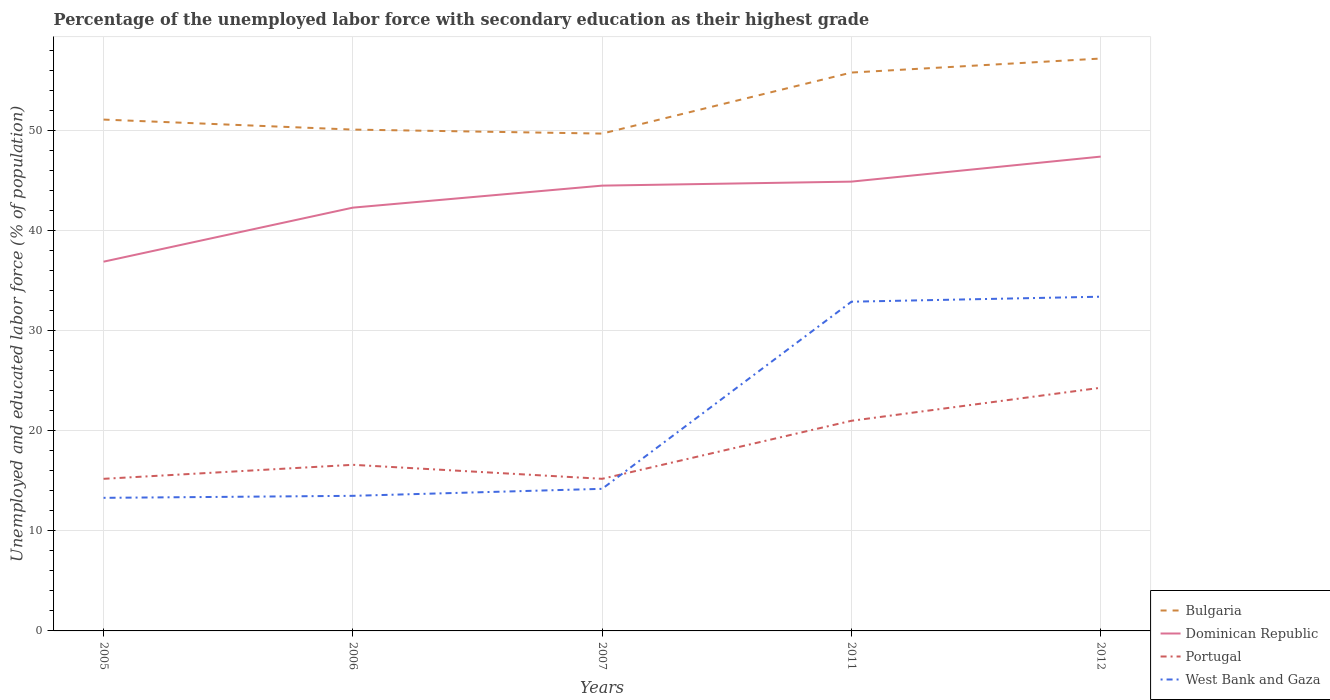How many different coloured lines are there?
Give a very brief answer. 4. Does the line corresponding to Dominican Republic intersect with the line corresponding to West Bank and Gaza?
Your answer should be compact. No. Is the number of lines equal to the number of legend labels?
Offer a very short reply. Yes. Across all years, what is the maximum percentage of the unemployed labor force with secondary education in West Bank and Gaza?
Offer a terse response. 13.3. What is the total percentage of the unemployed labor force with secondary education in Bulgaria in the graph?
Your answer should be very brief. -4.7. What is the difference between the highest and the lowest percentage of the unemployed labor force with secondary education in Dominican Republic?
Provide a succinct answer. 3. Is the percentage of the unemployed labor force with secondary education in West Bank and Gaza strictly greater than the percentage of the unemployed labor force with secondary education in Portugal over the years?
Your answer should be compact. No. How many lines are there?
Your response must be concise. 4. What is the difference between two consecutive major ticks on the Y-axis?
Your response must be concise. 10. Are the values on the major ticks of Y-axis written in scientific E-notation?
Offer a very short reply. No. Does the graph contain any zero values?
Offer a very short reply. No. How are the legend labels stacked?
Provide a succinct answer. Vertical. What is the title of the graph?
Ensure brevity in your answer.  Percentage of the unemployed labor force with secondary education as their highest grade. Does "Kyrgyz Republic" appear as one of the legend labels in the graph?
Your response must be concise. No. What is the label or title of the X-axis?
Offer a very short reply. Years. What is the label or title of the Y-axis?
Provide a succinct answer. Unemployed and educated labor force (% of population). What is the Unemployed and educated labor force (% of population) in Bulgaria in 2005?
Ensure brevity in your answer.  51.1. What is the Unemployed and educated labor force (% of population) in Dominican Republic in 2005?
Offer a terse response. 36.9. What is the Unemployed and educated labor force (% of population) of Portugal in 2005?
Make the answer very short. 15.2. What is the Unemployed and educated labor force (% of population) of West Bank and Gaza in 2005?
Ensure brevity in your answer.  13.3. What is the Unemployed and educated labor force (% of population) in Bulgaria in 2006?
Your answer should be compact. 50.1. What is the Unemployed and educated labor force (% of population) of Dominican Republic in 2006?
Offer a very short reply. 42.3. What is the Unemployed and educated labor force (% of population) of Portugal in 2006?
Provide a short and direct response. 16.6. What is the Unemployed and educated labor force (% of population) in Bulgaria in 2007?
Your answer should be compact. 49.7. What is the Unemployed and educated labor force (% of population) of Dominican Republic in 2007?
Keep it short and to the point. 44.5. What is the Unemployed and educated labor force (% of population) in Portugal in 2007?
Provide a succinct answer. 15.2. What is the Unemployed and educated labor force (% of population) in West Bank and Gaza in 2007?
Your answer should be very brief. 14.2. What is the Unemployed and educated labor force (% of population) of Bulgaria in 2011?
Offer a terse response. 55.8. What is the Unemployed and educated labor force (% of population) in Dominican Republic in 2011?
Offer a terse response. 44.9. What is the Unemployed and educated labor force (% of population) of Portugal in 2011?
Make the answer very short. 21. What is the Unemployed and educated labor force (% of population) in West Bank and Gaza in 2011?
Your answer should be compact. 32.9. What is the Unemployed and educated labor force (% of population) of Bulgaria in 2012?
Keep it short and to the point. 57.2. What is the Unemployed and educated labor force (% of population) of Dominican Republic in 2012?
Offer a terse response. 47.4. What is the Unemployed and educated labor force (% of population) in Portugal in 2012?
Offer a terse response. 24.3. What is the Unemployed and educated labor force (% of population) of West Bank and Gaza in 2012?
Your answer should be compact. 33.4. Across all years, what is the maximum Unemployed and educated labor force (% of population) of Bulgaria?
Offer a terse response. 57.2. Across all years, what is the maximum Unemployed and educated labor force (% of population) of Dominican Republic?
Provide a short and direct response. 47.4. Across all years, what is the maximum Unemployed and educated labor force (% of population) of Portugal?
Provide a short and direct response. 24.3. Across all years, what is the maximum Unemployed and educated labor force (% of population) of West Bank and Gaza?
Your response must be concise. 33.4. Across all years, what is the minimum Unemployed and educated labor force (% of population) of Bulgaria?
Make the answer very short. 49.7. Across all years, what is the minimum Unemployed and educated labor force (% of population) in Dominican Republic?
Make the answer very short. 36.9. Across all years, what is the minimum Unemployed and educated labor force (% of population) of Portugal?
Your answer should be very brief. 15.2. Across all years, what is the minimum Unemployed and educated labor force (% of population) in West Bank and Gaza?
Provide a short and direct response. 13.3. What is the total Unemployed and educated labor force (% of population) of Bulgaria in the graph?
Provide a succinct answer. 263.9. What is the total Unemployed and educated labor force (% of population) of Dominican Republic in the graph?
Your response must be concise. 216. What is the total Unemployed and educated labor force (% of population) in Portugal in the graph?
Keep it short and to the point. 92.3. What is the total Unemployed and educated labor force (% of population) of West Bank and Gaza in the graph?
Provide a succinct answer. 107.3. What is the difference between the Unemployed and educated labor force (% of population) of Dominican Republic in 2005 and that in 2006?
Make the answer very short. -5.4. What is the difference between the Unemployed and educated labor force (% of population) in Portugal in 2005 and that in 2006?
Your answer should be very brief. -1.4. What is the difference between the Unemployed and educated labor force (% of population) of Bulgaria in 2005 and that in 2007?
Provide a short and direct response. 1.4. What is the difference between the Unemployed and educated labor force (% of population) of Dominican Republic in 2005 and that in 2007?
Offer a very short reply. -7.6. What is the difference between the Unemployed and educated labor force (% of population) of West Bank and Gaza in 2005 and that in 2007?
Keep it short and to the point. -0.9. What is the difference between the Unemployed and educated labor force (% of population) of Bulgaria in 2005 and that in 2011?
Provide a short and direct response. -4.7. What is the difference between the Unemployed and educated labor force (% of population) of Dominican Republic in 2005 and that in 2011?
Make the answer very short. -8. What is the difference between the Unemployed and educated labor force (% of population) of West Bank and Gaza in 2005 and that in 2011?
Offer a terse response. -19.6. What is the difference between the Unemployed and educated labor force (% of population) of Bulgaria in 2005 and that in 2012?
Offer a terse response. -6.1. What is the difference between the Unemployed and educated labor force (% of population) in Portugal in 2005 and that in 2012?
Your answer should be compact. -9.1. What is the difference between the Unemployed and educated labor force (% of population) of West Bank and Gaza in 2005 and that in 2012?
Provide a succinct answer. -20.1. What is the difference between the Unemployed and educated labor force (% of population) of Dominican Republic in 2006 and that in 2007?
Your answer should be compact. -2.2. What is the difference between the Unemployed and educated labor force (% of population) of Bulgaria in 2006 and that in 2011?
Your response must be concise. -5.7. What is the difference between the Unemployed and educated labor force (% of population) of Dominican Republic in 2006 and that in 2011?
Ensure brevity in your answer.  -2.6. What is the difference between the Unemployed and educated labor force (% of population) of Portugal in 2006 and that in 2011?
Your answer should be compact. -4.4. What is the difference between the Unemployed and educated labor force (% of population) of West Bank and Gaza in 2006 and that in 2011?
Offer a terse response. -19.4. What is the difference between the Unemployed and educated labor force (% of population) of Bulgaria in 2006 and that in 2012?
Make the answer very short. -7.1. What is the difference between the Unemployed and educated labor force (% of population) in Portugal in 2006 and that in 2012?
Offer a terse response. -7.7. What is the difference between the Unemployed and educated labor force (% of population) of West Bank and Gaza in 2006 and that in 2012?
Give a very brief answer. -19.9. What is the difference between the Unemployed and educated labor force (% of population) in Bulgaria in 2007 and that in 2011?
Ensure brevity in your answer.  -6.1. What is the difference between the Unemployed and educated labor force (% of population) of West Bank and Gaza in 2007 and that in 2011?
Offer a very short reply. -18.7. What is the difference between the Unemployed and educated labor force (% of population) in Bulgaria in 2007 and that in 2012?
Your answer should be very brief. -7.5. What is the difference between the Unemployed and educated labor force (% of population) in Dominican Republic in 2007 and that in 2012?
Keep it short and to the point. -2.9. What is the difference between the Unemployed and educated labor force (% of population) of Portugal in 2007 and that in 2012?
Make the answer very short. -9.1. What is the difference between the Unemployed and educated labor force (% of population) in West Bank and Gaza in 2007 and that in 2012?
Make the answer very short. -19.2. What is the difference between the Unemployed and educated labor force (% of population) of Bulgaria in 2011 and that in 2012?
Provide a succinct answer. -1.4. What is the difference between the Unemployed and educated labor force (% of population) of Bulgaria in 2005 and the Unemployed and educated labor force (% of population) of Dominican Republic in 2006?
Provide a succinct answer. 8.8. What is the difference between the Unemployed and educated labor force (% of population) of Bulgaria in 2005 and the Unemployed and educated labor force (% of population) of Portugal in 2006?
Provide a short and direct response. 34.5. What is the difference between the Unemployed and educated labor force (% of population) in Bulgaria in 2005 and the Unemployed and educated labor force (% of population) in West Bank and Gaza in 2006?
Provide a short and direct response. 37.6. What is the difference between the Unemployed and educated labor force (% of population) in Dominican Republic in 2005 and the Unemployed and educated labor force (% of population) in Portugal in 2006?
Provide a succinct answer. 20.3. What is the difference between the Unemployed and educated labor force (% of population) of Dominican Republic in 2005 and the Unemployed and educated labor force (% of population) of West Bank and Gaza in 2006?
Provide a succinct answer. 23.4. What is the difference between the Unemployed and educated labor force (% of population) in Portugal in 2005 and the Unemployed and educated labor force (% of population) in West Bank and Gaza in 2006?
Provide a short and direct response. 1.7. What is the difference between the Unemployed and educated labor force (% of population) of Bulgaria in 2005 and the Unemployed and educated labor force (% of population) of Portugal in 2007?
Keep it short and to the point. 35.9. What is the difference between the Unemployed and educated labor force (% of population) of Bulgaria in 2005 and the Unemployed and educated labor force (% of population) of West Bank and Gaza in 2007?
Provide a succinct answer. 36.9. What is the difference between the Unemployed and educated labor force (% of population) of Dominican Republic in 2005 and the Unemployed and educated labor force (% of population) of Portugal in 2007?
Provide a succinct answer. 21.7. What is the difference between the Unemployed and educated labor force (% of population) in Dominican Republic in 2005 and the Unemployed and educated labor force (% of population) in West Bank and Gaza in 2007?
Provide a short and direct response. 22.7. What is the difference between the Unemployed and educated labor force (% of population) in Portugal in 2005 and the Unemployed and educated labor force (% of population) in West Bank and Gaza in 2007?
Ensure brevity in your answer.  1. What is the difference between the Unemployed and educated labor force (% of population) of Bulgaria in 2005 and the Unemployed and educated labor force (% of population) of Dominican Republic in 2011?
Your answer should be very brief. 6.2. What is the difference between the Unemployed and educated labor force (% of population) in Bulgaria in 2005 and the Unemployed and educated labor force (% of population) in Portugal in 2011?
Give a very brief answer. 30.1. What is the difference between the Unemployed and educated labor force (% of population) of Bulgaria in 2005 and the Unemployed and educated labor force (% of population) of West Bank and Gaza in 2011?
Your answer should be compact. 18.2. What is the difference between the Unemployed and educated labor force (% of population) in Dominican Republic in 2005 and the Unemployed and educated labor force (% of population) in Portugal in 2011?
Ensure brevity in your answer.  15.9. What is the difference between the Unemployed and educated labor force (% of population) of Portugal in 2005 and the Unemployed and educated labor force (% of population) of West Bank and Gaza in 2011?
Offer a very short reply. -17.7. What is the difference between the Unemployed and educated labor force (% of population) of Bulgaria in 2005 and the Unemployed and educated labor force (% of population) of Dominican Republic in 2012?
Your answer should be very brief. 3.7. What is the difference between the Unemployed and educated labor force (% of population) in Bulgaria in 2005 and the Unemployed and educated labor force (% of population) in Portugal in 2012?
Make the answer very short. 26.8. What is the difference between the Unemployed and educated labor force (% of population) of Portugal in 2005 and the Unemployed and educated labor force (% of population) of West Bank and Gaza in 2012?
Offer a very short reply. -18.2. What is the difference between the Unemployed and educated labor force (% of population) in Bulgaria in 2006 and the Unemployed and educated labor force (% of population) in Dominican Republic in 2007?
Provide a succinct answer. 5.6. What is the difference between the Unemployed and educated labor force (% of population) of Bulgaria in 2006 and the Unemployed and educated labor force (% of population) of Portugal in 2007?
Make the answer very short. 34.9. What is the difference between the Unemployed and educated labor force (% of population) in Bulgaria in 2006 and the Unemployed and educated labor force (% of population) in West Bank and Gaza in 2007?
Provide a short and direct response. 35.9. What is the difference between the Unemployed and educated labor force (% of population) of Dominican Republic in 2006 and the Unemployed and educated labor force (% of population) of Portugal in 2007?
Your answer should be very brief. 27.1. What is the difference between the Unemployed and educated labor force (% of population) of Dominican Republic in 2006 and the Unemployed and educated labor force (% of population) of West Bank and Gaza in 2007?
Give a very brief answer. 28.1. What is the difference between the Unemployed and educated labor force (% of population) in Bulgaria in 2006 and the Unemployed and educated labor force (% of population) in Portugal in 2011?
Your answer should be compact. 29.1. What is the difference between the Unemployed and educated labor force (% of population) in Bulgaria in 2006 and the Unemployed and educated labor force (% of population) in West Bank and Gaza in 2011?
Your answer should be compact. 17.2. What is the difference between the Unemployed and educated labor force (% of population) of Dominican Republic in 2006 and the Unemployed and educated labor force (% of population) of Portugal in 2011?
Give a very brief answer. 21.3. What is the difference between the Unemployed and educated labor force (% of population) in Portugal in 2006 and the Unemployed and educated labor force (% of population) in West Bank and Gaza in 2011?
Make the answer very short. -16.3. What is the difference between the Unemployed and educated labor force (% of population) in Bulgaria in 2006 and the Unemployed and educated labor force (% of population) in Dominican Republic in 2012?
Make the answer very short. 2.7. What is the difference between the Unemployed and educated labor force (% of population) of Bulgaria in 2006 and the Unemployed and educated labor force (% of population) of Portugal in 2012?
Your response must be concise. 25.8. What is the difference between the Unemployed and educated labor force (% of population) of Dominican Republic in 2006 and the Unemployed and educated labor force (% of population) of Portugal in 2012?
Keep it short and to the point. 18. What is the difference between the Unemployed and educated labor force (% of population) of Portugal in 2006 and the Unemployed and educated labor force (% of population) of West Bank and Gaza in 2012?
Keep it short and to the point. -16.8. What is the difference between the Unemployed and educated labor force (% of population) in Bulgaria in 2007 and the Unemployed and educated labor force (% of population) in Dominican Republic in 2011?
Provide a short and direct response. 4.8. What is the difference between the Unemployed and educated labor force (% of population) in Bulgaria in 2007 and the Unemployed and educated labor force (% of population) in Portugal in 2011?
Offer a terse response. 28.7. What is the difference between the Unemployed and educated labor force (% of population) of Portugal in 2007 and the Unemployed and educated labor force (% of population) of West Bank and Gaza in 2011?
Offer a terse response. -17.7. What is the difference between the Unemployed and educated labor force (% of population) of Bulgaria in 2007 and the Unemployed and educated labor force (% of population) of Portugal in 2012?
Offer a terse response. 25.4. What is the difference between the Unemployed and educated labor force (% of population) of Bulgaria in 2007 and the Unemployed and educated labor force (% of population) of West Bank and Gaza in 2012?
Ensure brevity in your answer.  16.3. What is the difference between the Unemployed and educated labor force (% of population) in Dominican Republic in 2007 and the Unemployed and educated labor force (% of population) in Portugal in 2012?
Make the answer very short. 20.2. What is the difference between the Unemployed and educated labor force (% of population) of Dominican Republic in 2007 and the Unemployed and educated labor force (% of population) of West Bank and Gaza in 2012?
Provide a succinct answer. 11.1. What is the difference between the Unemployed and educated labor force (% of population) of Portugal in 2007 and the Unemployed and educated labor force (% of population) of West Bank and Gaza in 2012?
Offer a very short reply. -18.2. What is the difference between the Unemployed and educated labor force (% of population) of Bulgaria in 2011 and the Unemployed and educated labor force (% of population) of Dominican Republic in 2012?
Ensure brevity in your answer.  8.4. What is the difference between the Unemployed and educated labor force (% of population) in Bulgaria in 2011 and the Unemployed and educated labor force (% of population) in Portugal in 2012?
Offer a terse response. 31.5. What is the difference between the Unemployed and educated labor force (% of population) of Bulgaria in 2011 and the Unemployed and educated labor force (% of population) of West Bank and Gaza in 2012?
Your answer should be compact. 22.4. What is the difference between the Unemployed and educated labor force (% of population) of Dominican Republic in 2011 and the Unemployed and educated labor force (% of population) of Portugal in 2012?
Your response must be concise. 20.6. What is the difference between the Unemployed and educated labor force (% of population) of Dominican Republic in 2011 and the Unemployed and educated labor force (% of population) of West Bank and Gaza in 2012?
Ensure brevity in your answer.  11.5. What is the average Unemployed and educated labor force (% of population) of Bulgaria per year?
Your answer should be very brief. 52.78. What is the average Unemployed and educated labor force (% of population) in Dominican Republic per year?
Your answer should be very brief. 43.2. What is the average Unemployed and educated labor force (% of population) of Portugal per year?
Keep it short and to the point. 18.46. What is the average Unemployed and educated labor force (% of population) of West Bank and Gaza per year?
Make the answer very short. 21.46. In the year 2005, what is the difference between the Unemployed and educated labor force (% of population) of Bulgaria and Unemployed and educated labor force (% of population) of Dominican Republic?
Keep it short and to the point. 14.2. In the year 2005, what is the difference between the Unemployed and educated labor force (% of population) in Bulgaria and Unemployed and educated labor force (% of population) in Portugal?
Your answer should be compact. 35.9. In the year 2005, what is the difference between the Unemployed and educated labor force (% of population) of Bulgaria and Unemployed and educated labor force (% of population) of West Bank and Gaza?
Provide a short and direct response. 37.8. In the year 2005, what is the difference between the Unemployed and educated labor force (% of population) of Dominican Republic and Unemployed and educated labor force (% of population) of Portugal?
Give a very brief answer. 21.7. In the year 2005, what is the difference between the Unemployed and educated labor force (% of population) of Dominican Republic and Unemployed and educated labor force (% of population) of West Bank and Gaza?
Provide a short and direct response. 23.6. In the year 2005, what is the difference between the Unemployed and educated labor force (% of population) of Portugal and Unemployed and educated labor force (% of population) of West Bank and Gaza?
Give a very brief answer. 1.9. In the year 2006, what is the difference between the Unemployed and educated labor force (% of population) in Bulgaria and Unemployed and educated labor force (% of population) in Dominican Republic?
Offer a terse response. 7.8. In the year 2006, what is the difference between the Unemployed and educated labor force (% of population) of Bulgaria and Unemployed and educated labor force (% of population) of Portugal?
Keep it short and to the point. 33.5. In the year 2006, what is the difference between the Unemployed and educated labor force (% of population) in Bulgaria and Unemployed and educated labor force (% of population) in West Bank and Gaza?
Provide a succinct answer. 36.6. In the year 2006, what is the difference between the Unemployed and educated labor force (% of population) in Dominican Republic and Unemployed and educated labor force (% of population) in Portugal?
Give a very brief answer. 25.7. In the year 2006, what is the difference between the Unemployed and educated labor force (% of population) in Dominican Republic and Unemployed and educated labor force (% of population) in West Bank and Gaza?
Ensure brevity in your answer.  28.8. In the year 2006, what is the difference between the Unemployed and educated labor force (% of population) of Portugal and Unemployed and educated labor force (% of population) of West Bank and Gaza?
Provide a short and direct response. 3.1. In the year 2007, what is the difference between the Unemployed and educated labor force (% of population) of Bulgaria and Unemployed and educated labor force (% of population) of Portugal?
Ensure brevity in your answer.  34.5. In the year 2007, what is the difference between the Unemployed and educated labor force (% of population) of Bulgaria and Unemployed and educated labor force (% of population) of West Bank and Gaza?
Provide a short and direct response. 35.5. In the year 2007, what is the difference between the Unemployed and educated labor force (% of population) of Dominican Republic and Unemployed and educated labor force (% of population) of Portugal?
Provide a succinct answer. 29.3. In the year 2007, what is the difference between the Unemployed and educated labor force (% of population) in Dominican Republic and Unemployed and educated labor force (% of population) in West Bank and Gaza?
Offer a very short reply. 30.3. In the year 2007, what is the difference between the Unemployed and educated labor force (% of population) in Portugal and Unemployed and educated labor force (% of population) in West Bank and Gaza?
Make the answer very short. 1. In the year 2011, what is the difference between the Unemployed and educated labor force (% of population) of Bulgaria and Unemployed and educated labor force (% of population) of Portugal?
Your answer should be very brief. 34.8. In the year 2011, what is the difference between the Unemployed and educated labor force (% of population) in Bulgaria and Unemployed and educated labor force (% of population) in West Bank and Gaza?
Offer a terse response. 22.9. In the year 2011, what is the difference between the Unemployed and educated labor force (% of population) in Dominican Republic and Unemployed and educated labor force (% of population) in Portugal?
Give a very brief answer. 23.9. In the year 2012, what is the difference between the Unemployed and educated labor force (% of population) in Bulgaria and Unemployed and educated labor force (% of population) in Portugal?
Ensure brevity in your answer.  32.9. In the year 2012, what is the difference between the Unemployed and educated labor force (% of population) in Bulgaria and Unemployed and educated labor force (% of population) in West Bank and Gaza?
Ensure brevity in your answer.  23.8. In the year 2012, what is the difference between the Unemployed and educated labor force (% of population) in Dominican Republic and Unemployed and educated labor force (% of population) in Portugal?
Ensure brevity in your answer.  23.1. In the year 2012, what is the difference between the Unemployed and educated labor force (% of population) in Portugal and Unemployed and educated labor force (% of population) in West Bank and Gaza?
Give a very brief answer. -9.1. What is the ratio of the Unemployed and educated labor force (% of population) in Dominican Republic in 2005 to that in 2006?
Keep it short and to the point. 0.87. What is the ratio of the Unemployed and educated labor force (% of population) of Portugal in 2005 to that in 2006?
Give a very brief answer. 0.92. What is the ratio of the Unemployed and educated labor force (% of population) in West Bank and Gaza in 2005 to that in 2006?
Provide a succinct answer. 0.99. What is the ratio of the Unemployed and educated labor force (% of population) of Bulgaria in 2005 to that in 2007?
Ensure brevity in your answer.  1.03. What is the ratio of the Unemployed and educated labor force (% of population) in Dominican Republic in 2005 to that in 2007?
Ensure brevity in your answer.  0.83. What is the ratio of the Unemployed and educated labor force (% of population) of Portugal in 2005 to that in 2007?
Ensure brevity in your answer.  1. What is the ratio of the Unemployed and educated labor force (% of population) in West Bank and Gaza in 2005 to that in 2007?
Provide a succinct answer. 0.94. What is the ratio of the Unemployed and educated labor force (% of population) in Bulgaria in 2005 to that in 2011?
Your answer should be very brief. 0.92. What is the ratio of the Unemployed and educated labor force (% of population) in Dominican Republic in 2005 to that in 2011?
Ensure brevity in your answer.  0.82. What is the ratio of the Unemployed and educated labor force (% of population) of Portugal in 2005 to that in 2011?
Your answer should be compact. 0.72. What is the ratio of the Unemployed and educated labor force (% of population) in West Bank and Gaza in 2005 to that in 2011?
Keep it short and to the point. 0.4. What is the ratio of the Unemployed and educated labor force (% of population) in Bulgaria in 2005 to that in 2012?
Your response must be concise. 0.89. What is the ratio of the Unemployed and educated labor force (% of population) in Dominican Republic in 2005 to that in 2012?
Your answer should be very brief. 0.78. What is the ratio of the Unemployed and educated labor force (% of population) in Portugal in 2005 to that in 2012?
Ensure brevity in your answer.  0.63. What is the ratio of the Unemployed and educated labor force (% of population) in West Bank and Gaza in 2005 to that in 2012?
Provide a succinct answer. 0.4. What is the ratio of the Unemployed and educated labor force (% of population) in Bulgaria in 2006 to that in 2007?
Make the answer very short. 1.01. What is the ratio of the Unemployed and educated labor force (% of population) in Dominican Republic in 2006 to that in 2007?
Make the answer very short. 0.95. What is the ratio of the Unemployed and educated labor force (% of population) in Portugal in 2006 to that in 2007?
Provide a succinct answer. 1.09. What is the ratio of the Unemployed and educated labor force (% of population) in West Bank and Gaza in 2006 to that in 2007?
Ensure brevity in your answer.  0.95. What is the ratio of the Unemployed and educated labor force (% of population) in Bulgaria in 2006 to that in 2011?
Your response must be concise. 0.9. What is the ratio of the Unemployed and educated labor force (% of population) of Dominican Republic in 2006 to that in 2011?
Your answer should be compact. 0.94. What is the ratio of the Unemployed and educated labor force (% of population) in Portugal in 2006 to that in 2011?
Your answer should be very brief. 0.79. What is the ratio of the Unemployed and educated labor force (% of population) of West Bank and Gaza in 2006 to that in 2011?
Offer a terse response. 0.41. What is the ratio of the Unemployed and educated labor force (% of population) of Bulgaria in 2006 to that in 2012?
Ensure brevity in your answer.  0.88. What is the ratio of the Unemployed and educated labor force (% of population) in Dominican Republic in 2006 to that in 2012?
Ensure brevity in your answer.  0.89. What is the ratio of the Unemployed and educated labor force (% of population) of Portugal in 2006 to that in 2012?
Provide a short and direct response. 0.68. What is the ratio of the Unemployed and educated labor force (% of population) in West Bank and Gaza in 2006 to that in 2012?
Offer a very short reply. 0.4. What is the ratio of the Unemployed and educated labor force (% of population) of Bulgaria in 2007 to that in 2011?
Provide a succinct answer. 0.89. What is the ratio of the Unemployed and educated labor force (% of population) of Portugal in 2007 to that in 2011?
Your answer should be very brief. 0.72. What is the ratio of the Unemployed and educated labor force (% of population) in West Bank and Gaza in 2007 to that in 2011?
Offer a terse response. 0.43. What is the ratio of the Unemployed and educated labor force (% of population) of Bulgaria in 2007 to that in 2012?
Your answer should be very brief. 0.87. What is the ratio of the Unemployed and educated labor force (% of population) of Dominican Republic in 2007 to that in 2012?
Offer a very short reply. 0.94. What is the ratio of the Unemployed and educated labor force (% of population) in Portugal in 2007 to that in 2012?
Give a very brief answer. 0.63. What is the ratio of the Unemployed and educated labor force (% of population) of West Bank and Gaza in 2007 to that in 2012?
Offer a terse response. 0.43. What is the ratio of the Unemployed and educated labor force (% of population) of Bulgaria in 2011 to that in 2012?
Ensure brevity in your answer.  0.98. What is the ratio of the Unemployed and educated labor force (% of population) of Dominican Republic in 2011 to that in 2012?
Offer a very short reply. 0.95. What is the ratio of the Unemployed and educated labor force (% of population) of Portugal in 2011 to that in 2012?
Make the answer very short. 0.86. What is the difference between the highest and the second highest Unemployed and educated labor force (% of population) in Bulgaria?
Provide a short and direct response. 1.4. What is the difference between the highest and the second highest Unemployed and educated labor force (% of population) of Portugal?
Your response must be concise. 3.3. What is the difference between the highest and the second highest Unemployed and educated labor force (% of population) of West Bank and Gaza?
Your response must be concise. 0.5. What is the difference between the highest and the lowest Unemployed and educated labor force (% of population) in Dominican Republic?
Give a very brief answer. 10.5. What is the difference between the highest and the lowest Unemployed and educated labor force (% of population) of Portugal?
Provide a short and direct response. 9.1. What is the difference between the highest and the lowest Unemployed and educated labor force (% of population) of West Bank and Gaza?
Your answer should be very brief. 20.1. 